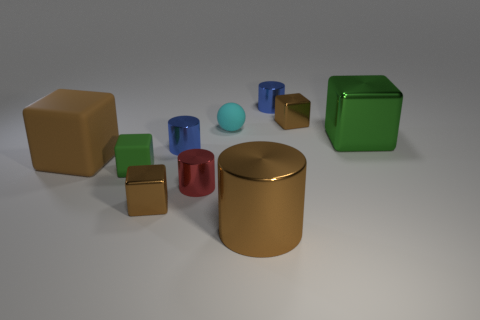How big is the green block on the right side of the tiny brown object in front of the cyan matte sphere?
Make the answer very short. Large. The small matte cube has what color?
Keep it short and to the point. Green. What number of big metal objects are to the left of the tiny metallic cube that is on the left side of the tiny matte sphere?
Provide a short and direct response. 0. There is a blue metallic thing on the left side of the small red metal object; are there any small matte cubes behind it?
Your response must be concise. No. Are there any tiny red metal things to the left of the large matte block?
Your answer should be very brief. No. There is a large brown rubber thing left of the small green rubber block; does it have the same shape as the small cyan rubber thing?
Make the answer very short. No. What number of other tiny shiny things have the same shape as the green shiny thing?
Make the answer very short. 2. Are there any cyan spheres that have the same material as the tiny green object?
Make the answer very short. Yes. What is the material of the tiny cylinder in front of the blue cylinder in front of the cyan matte object?
Make the answer very short. Metal. How big is the green block in front of the large green metal object?
Offer a terse response. Small. 